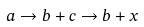Convert formula to latex. <formula><loc_0><loc_0><loc_500><loc_500>a \rightarrow b + c \rightarrow b + x</formula> 